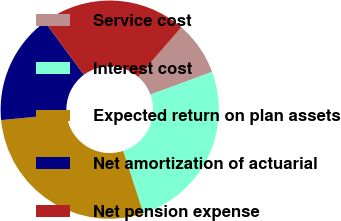Convert chart to OTSL. <chart><loc_0><loc_0><loc_500><loc_500><pie_chart><fcel>Service cost<fcel>Interest cost<fcel>Expected return on plan assets<fcel>Net amortization of actuarial<fcel>Net pension expense<nl><fcel>7.99%<fcel>25.61%<fcel>28.48%<fcel>16.4%<fcel>21.52%<nl></chart> 